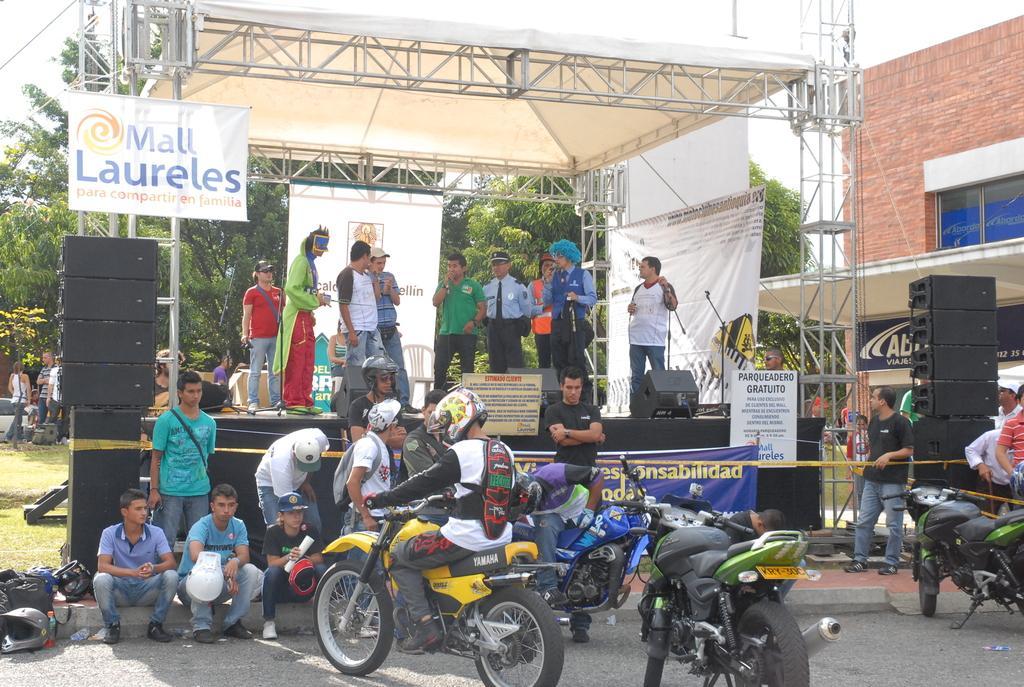How would you summarize this image in a sentence or two? There are four motorcycles. Two persons are sitting wearing helmets. In the back there are many people. Some are sitting and some are standing. Some are wearing caps and helmets. There is a stage. On the stage there are banners and speakers. Also there are speakers on the sides. In the background there are trees. On the right side there is a building with windows. 